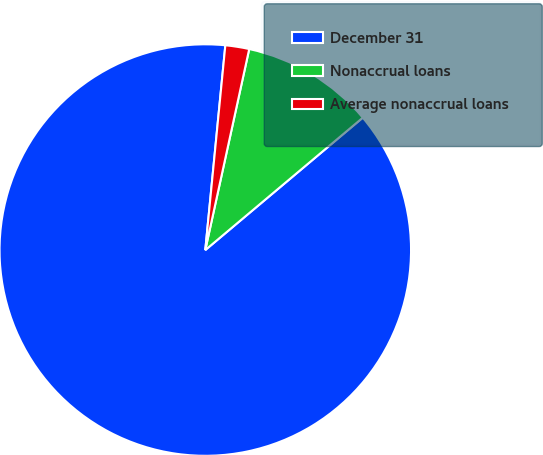Convert chart to OTSL. <chart><loc_0><loc_0><loc_500><loc_500><pie_chart><fcel>December 31<fcel>Nonaccrual loans<fcel>Average nonaccrual loans<nl><fcel>87.67%<fcel>10.45%<fcel>1.87%<nl></chart> 